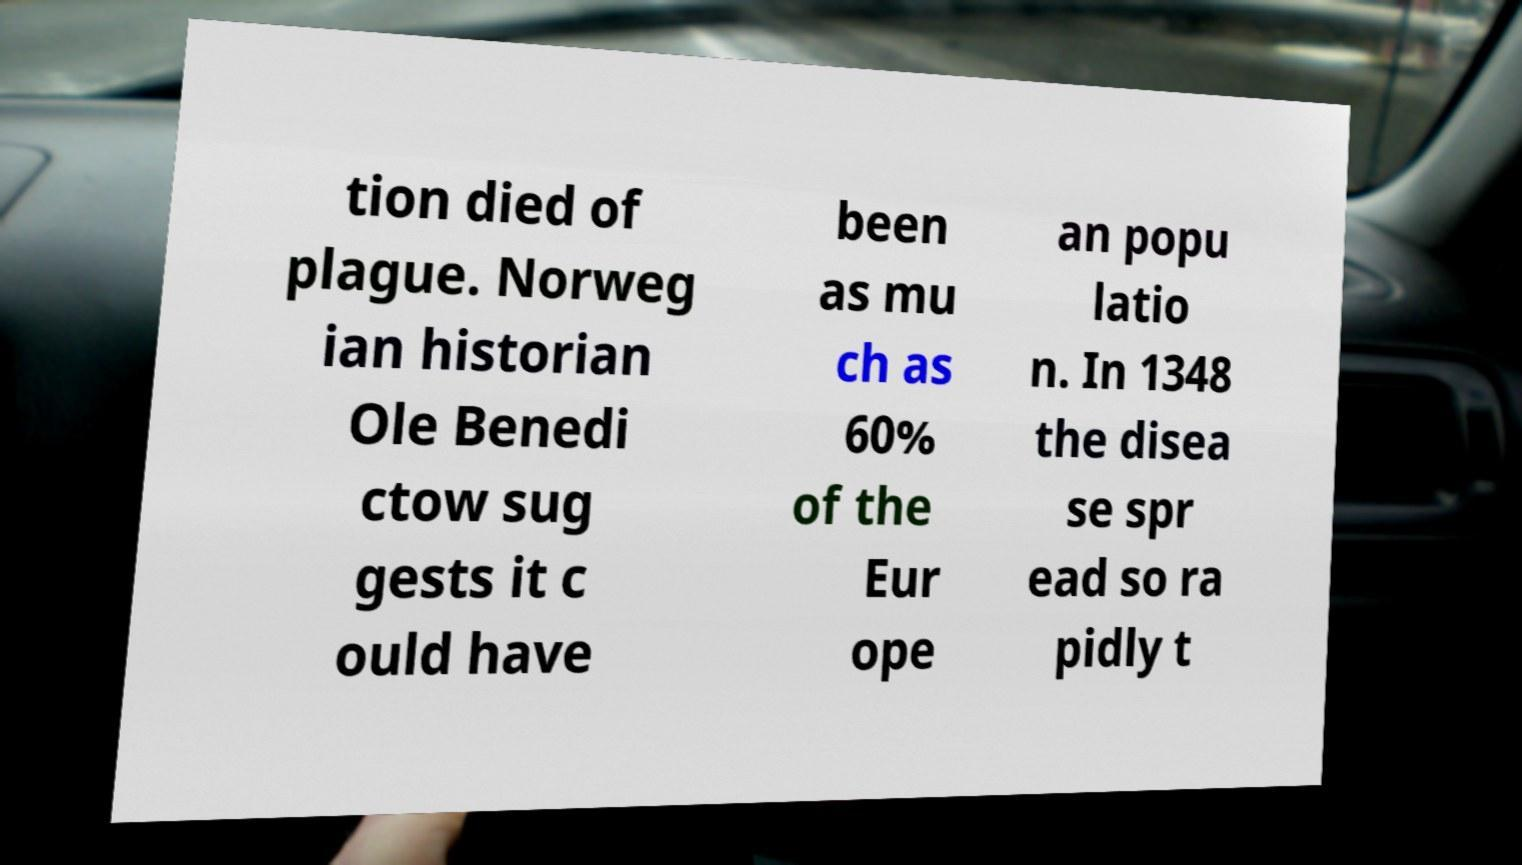Can you accurately transcribe the text from the provided image for me? tion died of plague. Norweg ian historian Ole Benedi ctow sug gests it c ould have been as mu ch as 60% of the Eur ope an popu latio n. In 1348 the disea se spr ead so ra pidly t 